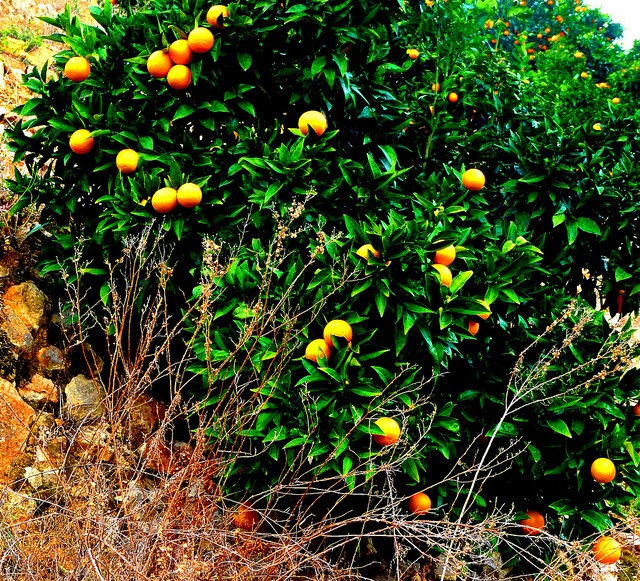Describe the objects in this image and their specific colors. I can see orange in white, black, darkgreen, green, and yellow tones, orange in white, yellow, red, and maroon tones, orange in white, yellow, red, and orange tones, orange in white, yellow, khaki, and orange tones, and orange in white, yellow, red, and orange tones in this image. 